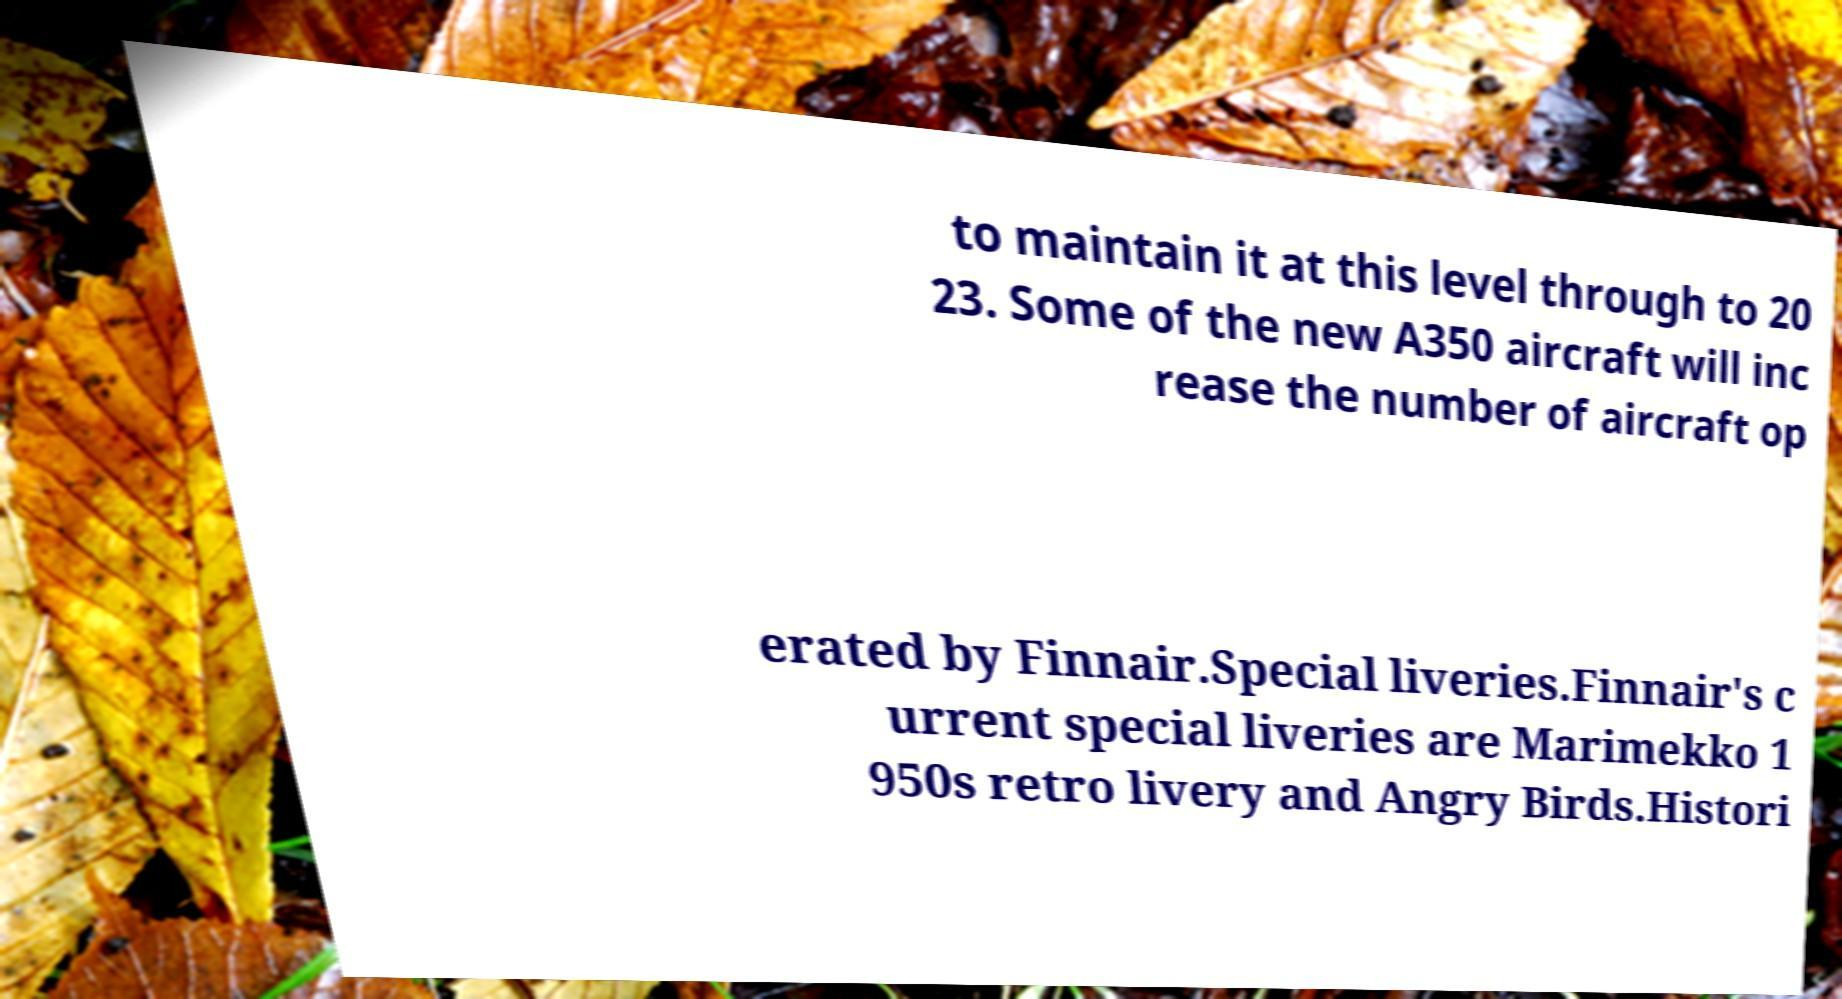For documentation purposes, I need the text within this image transcribed. Could you provide that? to maintain it at this level through to 20 23. Some of the new A350 aircraft will inc rease the number of aircraft op erated by Finnair.Special liveries.Finnair's c urrent special liveries are Marimekko 1 950s retro livery and Angry Birds.Histori 